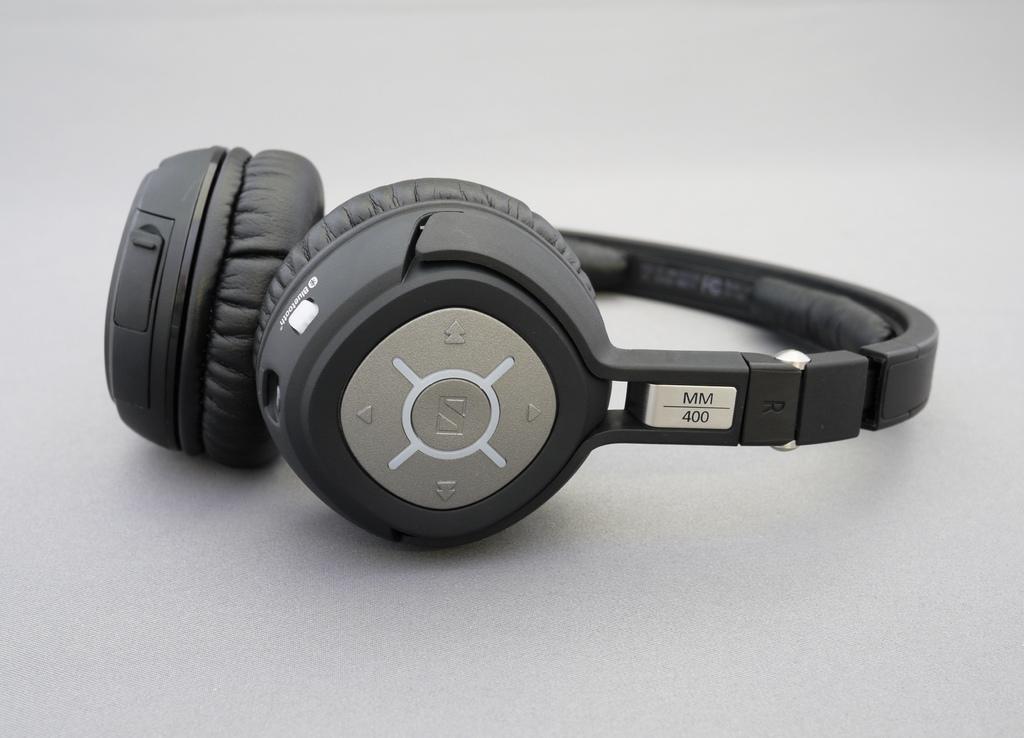Can you describe this image briefly? In this image we can see a headphones on a surface. On the headphones there are buttons. 